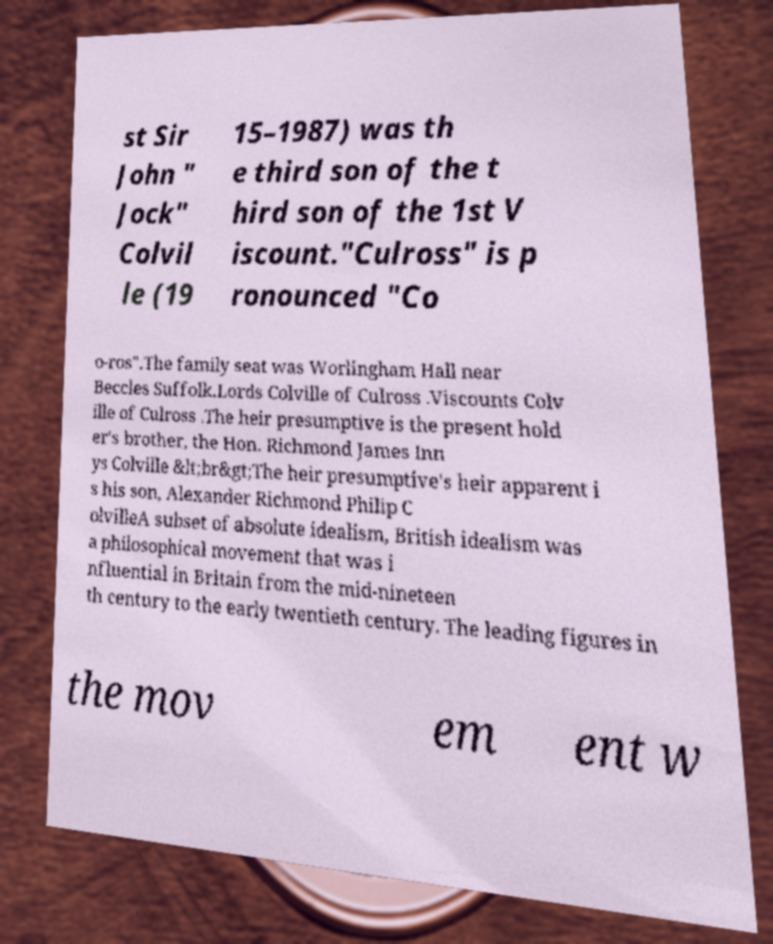Please read and relay the text visible in this image. What does it say? st Sir John " Jock" Colvil le (19 15–1987) was th e third son of the t hird son of the 1st V iscount."Culross" is p ronounced "Co o-ros".The family seat was Worlingham Hall near Beccles Suffolk.Lords Colville of Culross .Viscounts Colv ille of Culross .The heir presumptive is the present hold er's brother, the Hon. Richmond James Inn ys Colville &lt;br&gt;The heir presumptive's heir apparent i s his son, Alexander Richmond Philip C olvilleA subset of absolute idealism, British idealism was a philosophical movement that was i nfluential in Britain from the mid-nineteen th century to the early twentieth century. The leading figures in the mov em ent w 